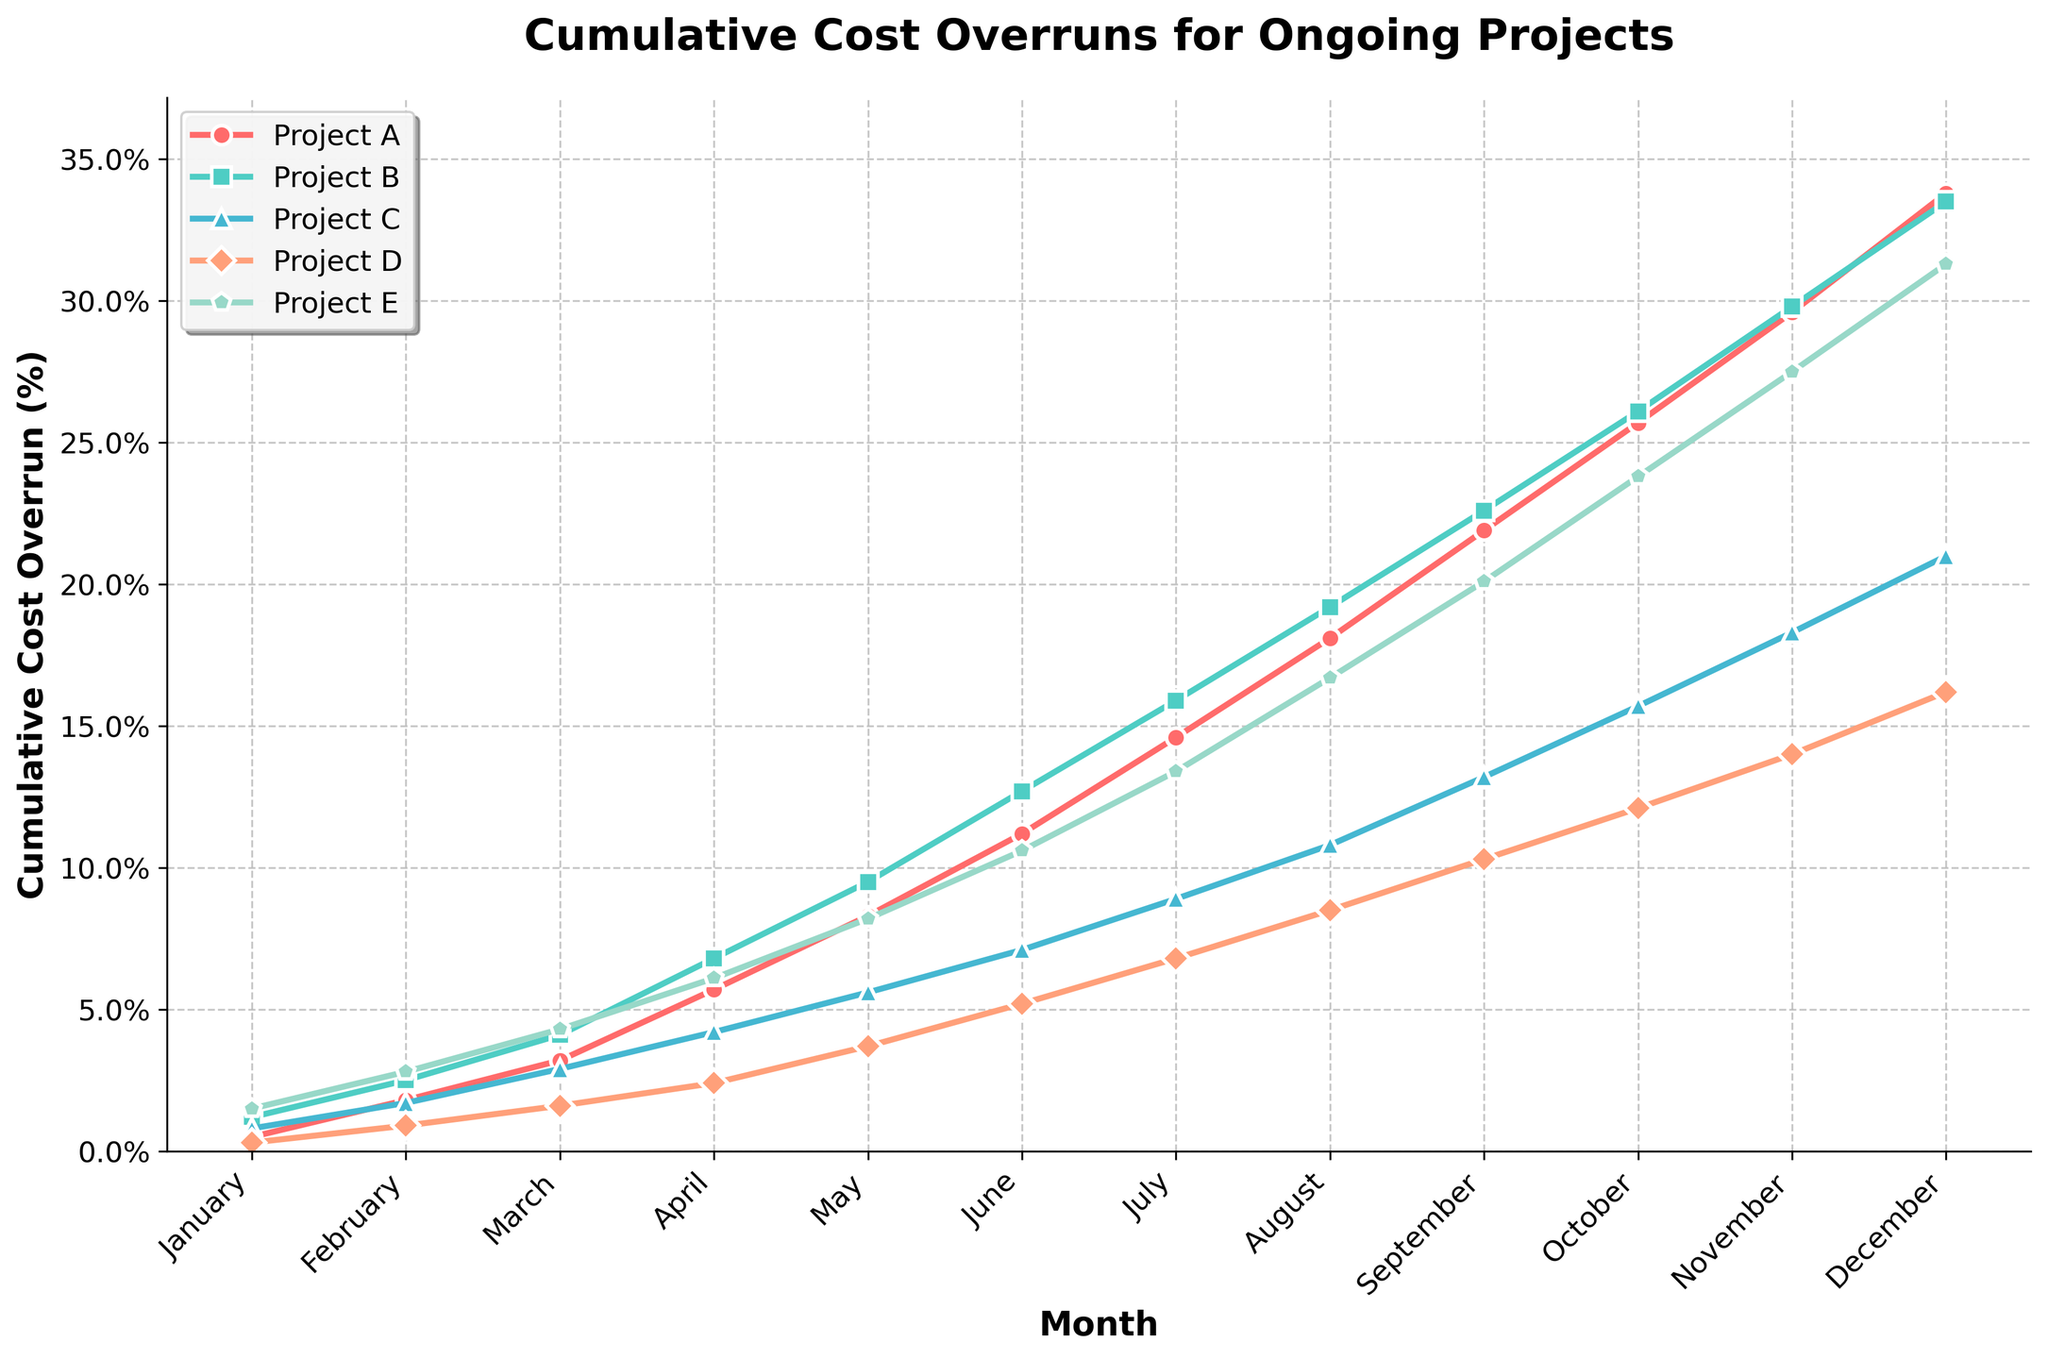Which project had the highest cumulative cost overrun in December? To find the project with the highest cumulative cost overrun in December, locate December on the x-axis, then identify the line that reaches the highest point. This line represents Project A, which reaches approximately 33.8%.
Answer: Project A Which months saw Project C's cumulative cost overrun exceed 10%? First, find the line representing Project C (blue color with triangle markers), then identify the points where the line crosses the 10% mark on the y-axis. The line exceeds this threshold in August, September, October, November, and December.
Answer: August, September, October, November, December How does the cumulative cost overrun for Project D in July compare to that of Project B in March? Identify the data points for Project D in July (~6.8%) and Project B in March (~4.1%). Compare these values to see which one is higher. Project D's cumulative cost overrun in July is higher than Project B's in March.
Answer: Project D's overrun in July is higher What's the average cumulative cost overrun percentage for Project E over the year? To calculate the average, add up all the monthly cumulative cost overrun values for Project E: 1.5 + 2.8 + 4.3 + 6.1 + 8.2 + 10.6 + 13.4 + 16.7 + 20.1 + 23.8 + 27.5 + 31.3. The sum is 166.3. Divide this sum by 12 (number of months): 166.3 / 12 = ~13.86.
Answer: ~13.86% Between which two consecutive months did Project A experience the largest increase in cost overrun percentage? To find the largest increase, examine the difference in cumulative cost overrun percentage between each consecutive month for Project A: (1.8 - 0.5), (3.2 - 1.8), (5.7 - 3.2), (8.3 - 5.7), (11.2 - 8.3), (14.6 - 11.2), (18.1 - 14.6), (21.9 - 18.1), (25.7 - 21.9), (29.6 - 25.7), (33.8 - 29.6). The largest increase is 4.2 between November and December.
Answer: November to December By December, what is the difference in cumulative cost overrun percentages between Project B and Project C? In December, Project B's cumulative cost overrun is 33.5%, and Project C's is 21%. Subtract Project C's value from Project B's: 33.5 - 21 = 12.5.
Answer: 12.5% Which project had the least cumulative cost overrun in April? Identify the data points in April and find the one with the lowest value. Project D has the lowest cumulative cost overrun in April with approximately 2.4%.
Answer: Project D What's the total cumulative cost overrun for Project B from January to June? Sum the cumulative cost overrun percentages for Project B from January to June: 1.2 + 2.5 + 4.1 + 6.8 + 9.5 + 12.7 = 36.8.
Answer: 36.8% What is the visual trend of Project E's cumulative cost overrun over the year? Locate the line representing Project E and observe its pattern over the months. The line consistently rises, indicating a continual increase in cumulative cost overrun for Project E throughout the year.
Answer: Continuous increase How does the cumulative cost overrun of the project with the highest value in November compare to that of the project with the lowest value in the same month? Identify the highest and lowest cumulative cost overrun percentages in November. The highest is Project A at 29.6%, and the lowest is Project D at 14%. The difference is 29.6 - 14 = 15.6 percentage points.
Answer: 15.6 percentage points 